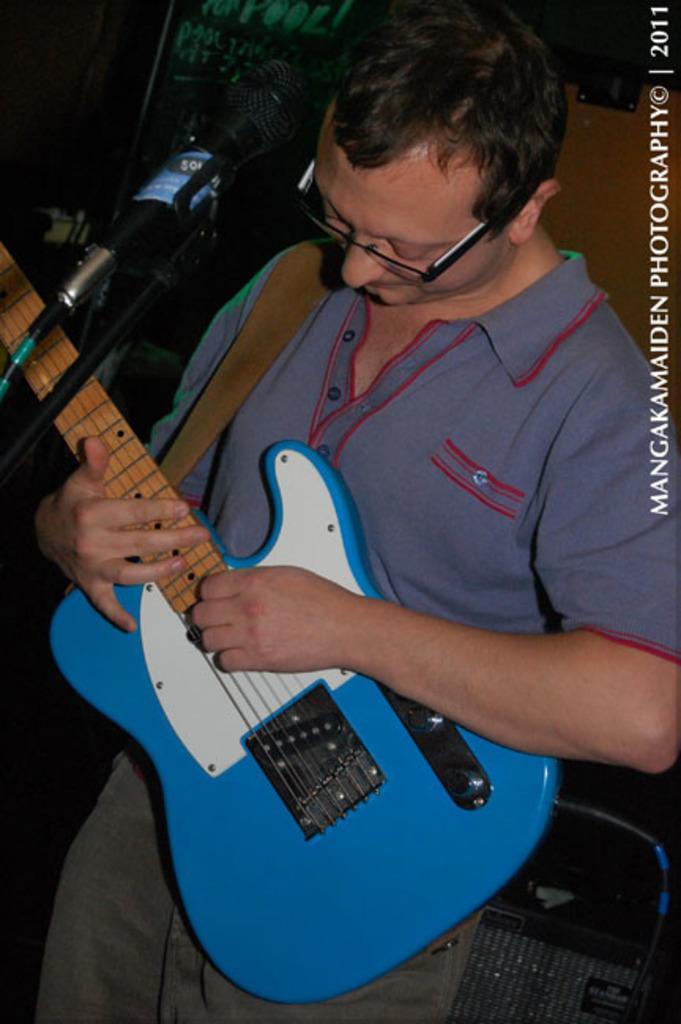How would you summarize this image in a sentence or two? In the middle of this image, there is a person in a gray color t-shirt, holding a guitar and playing. In front of him, there is a mic attached to a stand. On the top right, there is a watermark. In the background, there are other objects. 